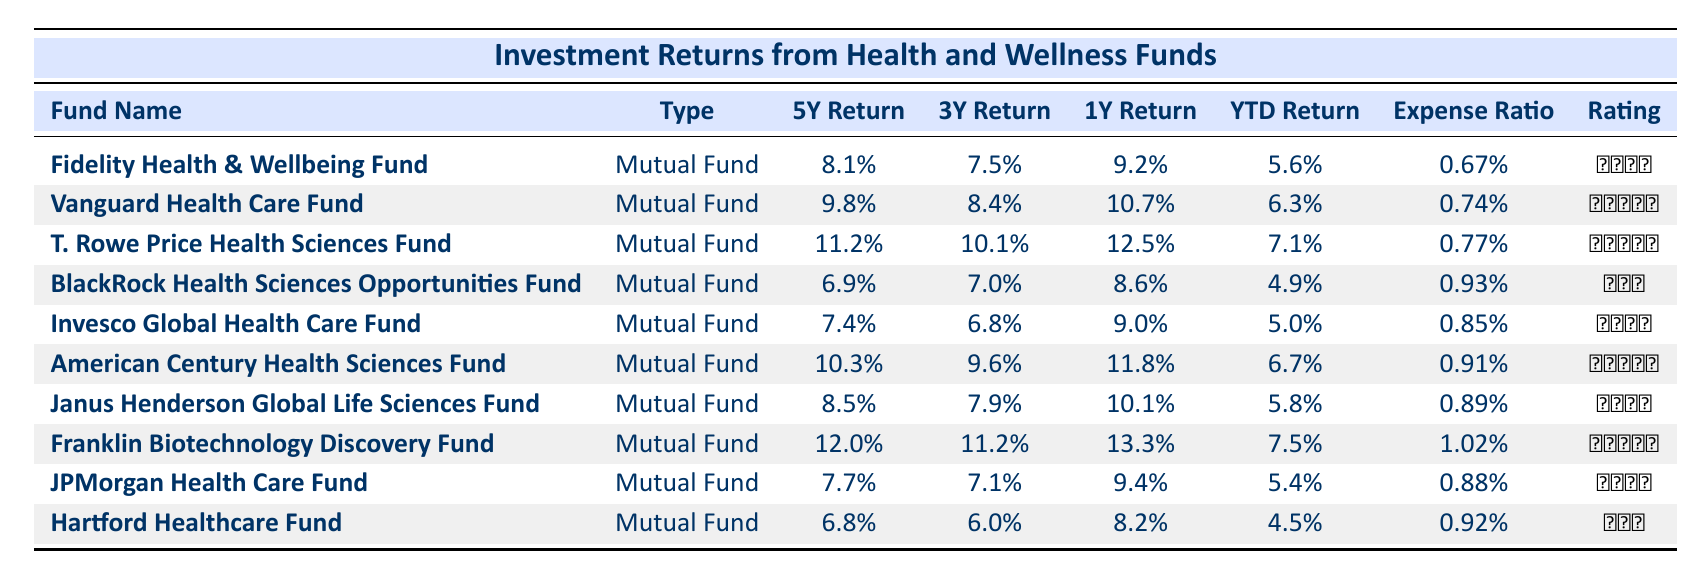What is the highest 5-year annualized return among the funds listed? Looking at the "5Y Return" column, the highest value is 12.0%, which corresponds to the Franklin Biotechnology Discovery Fund.
Answer: 12.0% Which fund has the lowest expense ratio? The "Expense Ratio" column shows the values, and the lowest expense ratio is 0.67% for the Fidelity Health & Wellbeing Fund.
Answer: 0.67% What is the average 1-year return of all funds? Summing the 1-year returns: (9.2 + 10.7 + 12.5 + 8.6 + 9.0 + 11.8 + 10.1 + 13.3 + 9.4 + 8.2) = 92.4. There are 10 funds, so the average is 92.4 / 10 = 9.24%.
Answer: 9.24% Is the Vanguard Health Care Fund rated higher than the Hartford Healthcare Fund? The Vanguard Health Care Fund has a rating of ★★★★★, whereas the Hartford Healthcare Fund has a rating of ★★★. Therefore, Vanguard has a higher rating.
Answer: Yes Which fund had the best year-to-date return? The "YTD Return" column shows that the Franklin Biotechnology Discovery Fund has the highest YTD return at 7.5%.
Answer: 7.5% What is the difference between the 5-year annualized return of the T. Rowe Price Health Sciences Fund and the BlackRock Health Sciences Opportunities Fund? The 5-year annualized return for T. Rowe Price is 11.2% and for BlackRock is 6.9%. The difference is 11.2% - 6.9% = 4.3%.
Answer: 4.3% Does the Invesco Global Health Care Fund have a 3-year annualized return that is higher than the YTD return of the Fidelity Health & Wellbeing Fund? The 3-year annualized return of Invesco is 6.8%, and the YTD return for Fidelity is 5.6%. Since 6.8% is greater than 5.6%, Invesco does have a higher 3-year annualized return.
Answer: Yes Which fund had the highest reported 1-year return and what was the percentage? The 1-year return for Franklin Biotechnology Discovery Fund is 13.3%, which is the highest among all the funds listed.
Answer: 13.3% What is the average 5-year annualized return across the funds? Summing the 5-year returns: (8.1 + 9.8 + 11.2 + 6.9 + 7.4 + 10.3 + 8.5 + 12.0 + 7.7 + 6.8) = 88.6. With 10 funds, the average is 88.6 / 10 = 8.86%.
Answer: 8.86% 